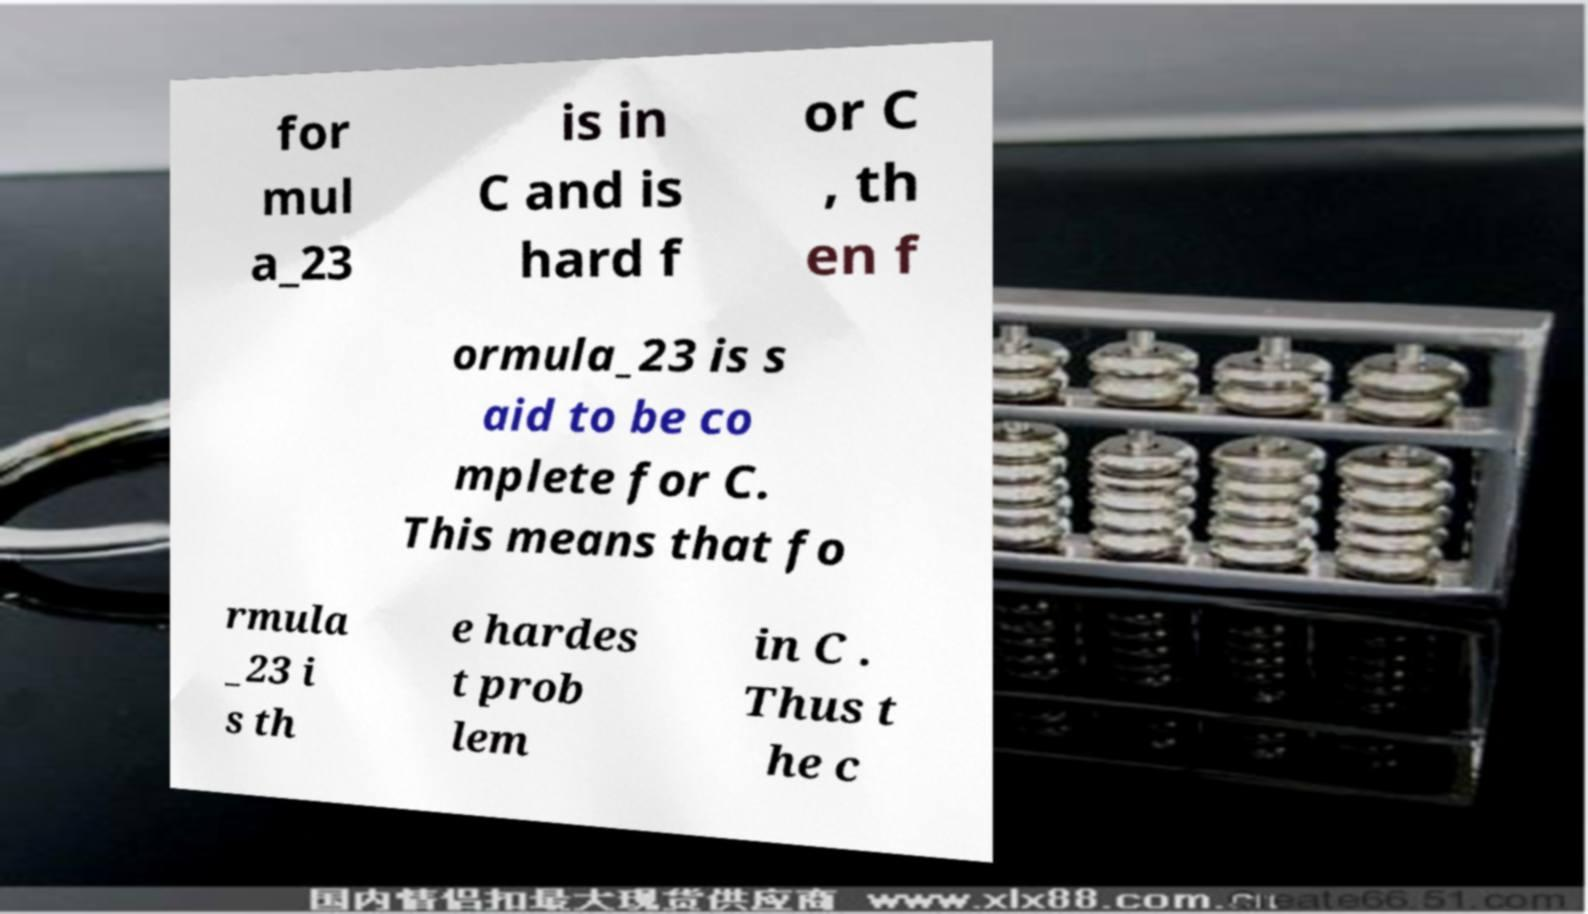Can you accurately transcribe the text from the provided image for me? for mul a_23 is in C and is hard f or C , th en f ormula_23 is s aid to be co mplete for C. This means that fo rmula _23 i s th e hardes t prob lem in C . Thus t he c 